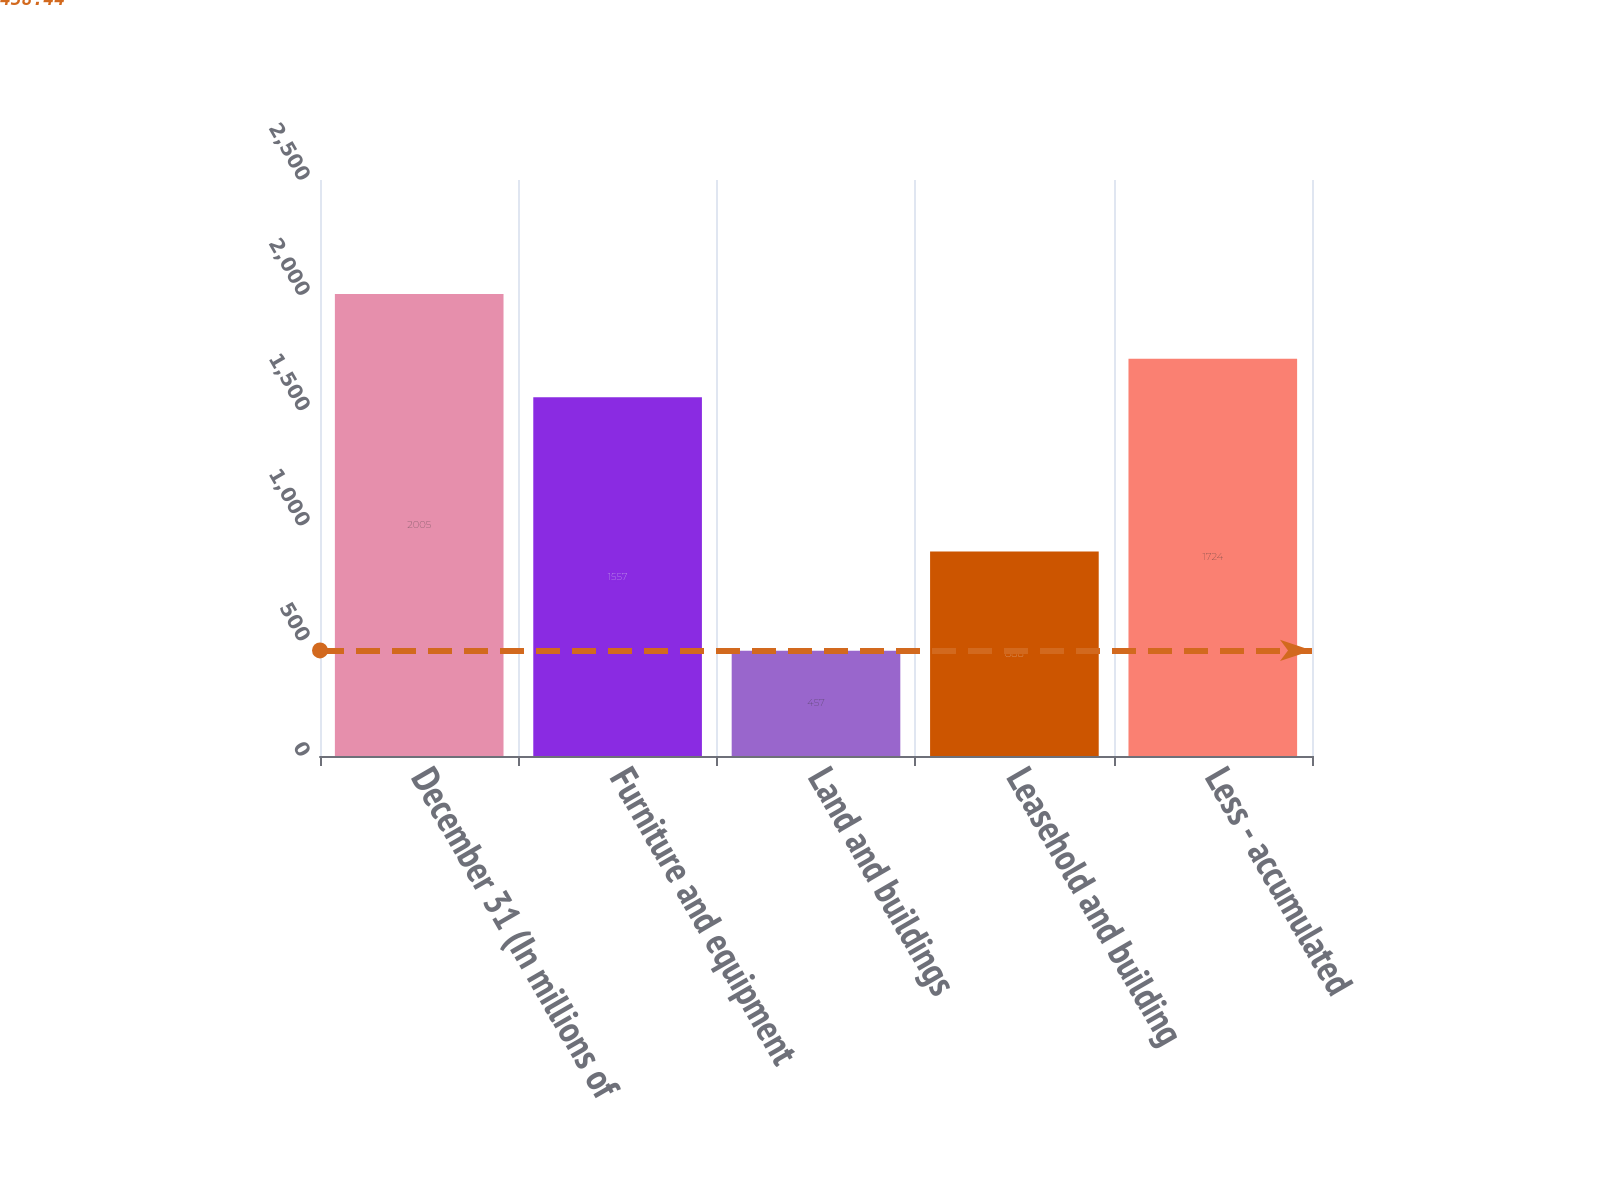<chart> <loc_0><loc_0><loc_500><loc_500><bar_chart><fcel>December 31 (In millions of<fcel>Furniture and equipment<fcel>Land and buildings<fcel>Leasehold and building<fcel>Less - accumulated<nl><fcel>2005<fcel>1557<fcel>457<fcel>888<fcel>1724<nl></chart> 